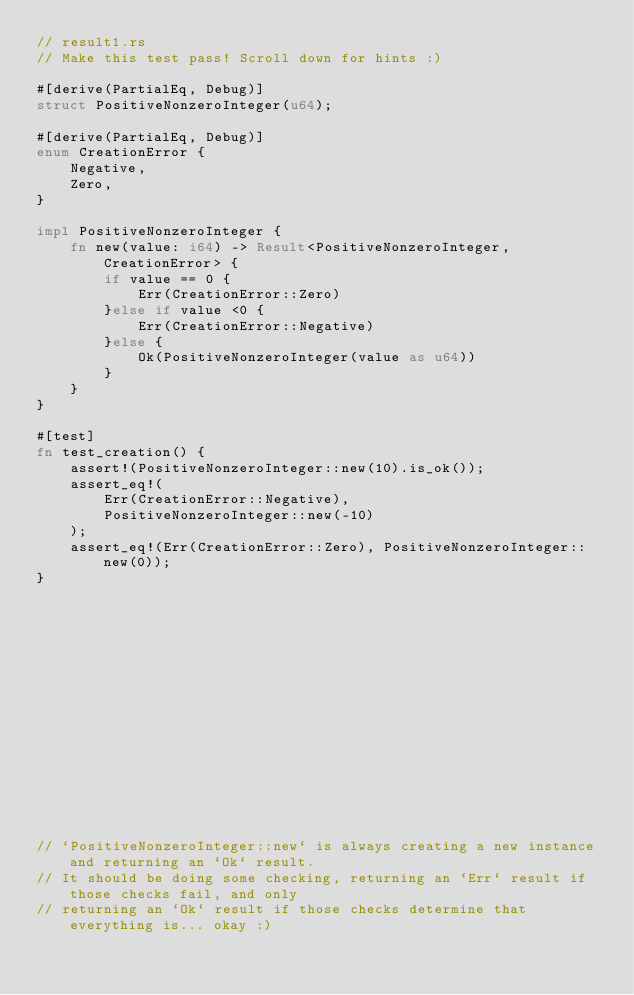Convert code to text. <code><loc_0><loc_0><loc_500><loc_500><_Rust_>// result1.rs
// Make this test pass! Scroll down for hints :)

#[derive(PartialEq, Debug)]
struct PositiveNonzeroInteger(u64);

#[derive(PartialEq, Debug)]
enum CreationError {
    Negative,
    Zero,
}

impl PositiveNonzeroInteger {
    fn new(value: i64) -> Result<PositiveNonzeroInteger, CreationError> {
        if value == 0 {
            Err(CreationError::Zero)
        }else if value <0 {
            Err(CreationError::Negative)
        }else {
            Ok(PositiveNonzeroInteger(value as u64))
        }
    }
}

#[test]
fn test_creation() {
    assert!(PositiveNonzeroInteger::new(10).is_ok());
    assert_eq!(
        Err(CreationError::Negative),
        PositiveNonzeroInteger::new(-10)
    );
    assert_eq!(Err(CreationError::Zero), PositiveNonzeroInteger::new(0));
}
















// `PositiveNonzeroInteger::new` is always creating a new instance and returning an `Ok` result.
// It should be doing some checking, returning an `Err` result if those checks fail, and only
// returning an `Ok` result if those checks determine that everything is... okay :)
</code> 